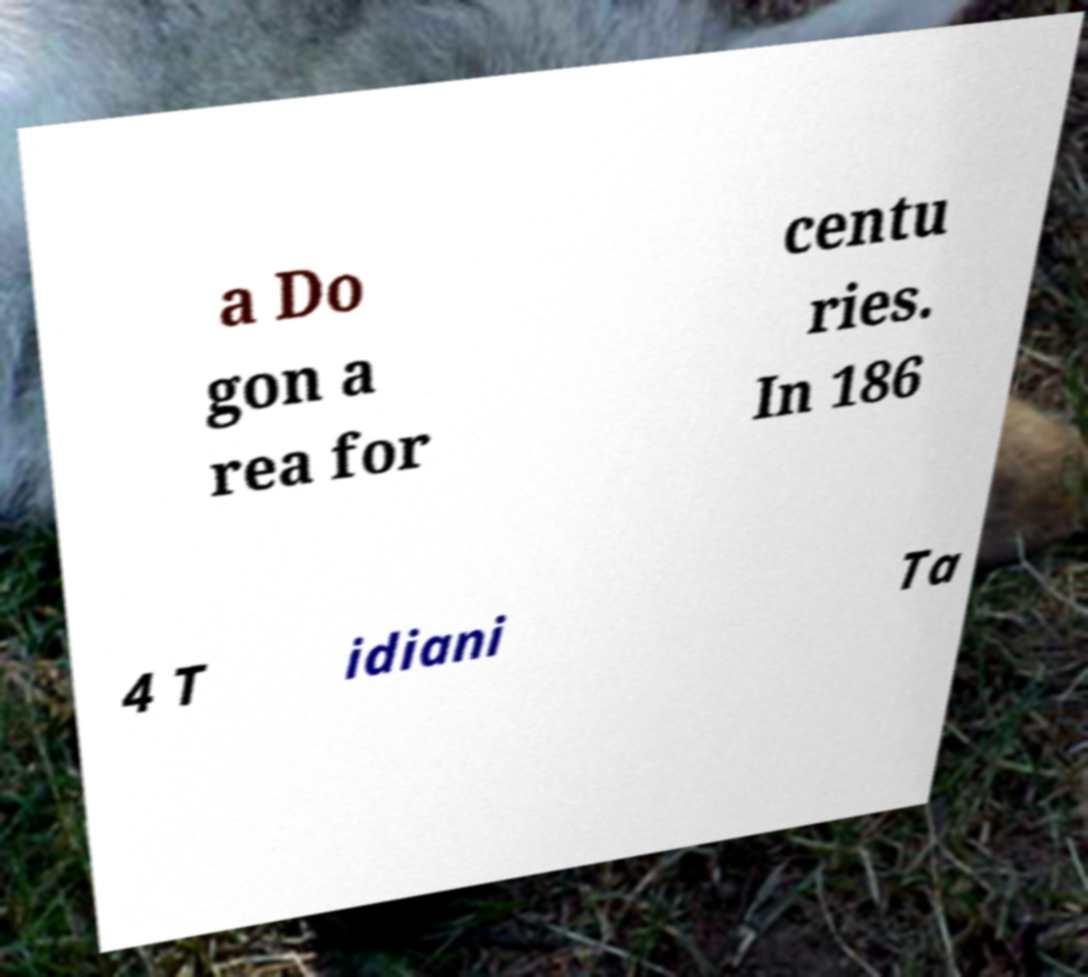For documentation purposes, I need the text within this image transcribed. Could you provide that? a Do gon a rea for centu ries. In 186 4 T idiani Ta 